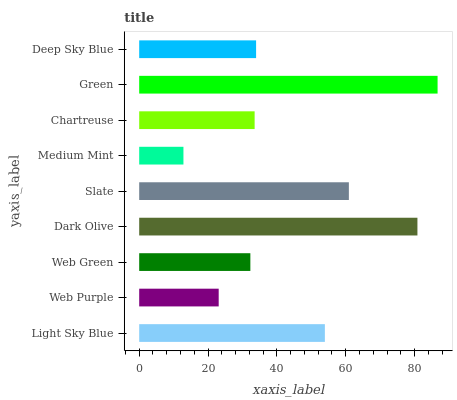Is Medium Mint the minimum?
Answer yes or no. Yes. Is Green the maximum?
Answer yes or no. Yes. Is Web Purple the minimum?
Answer yes or no. No. Is Web Purple the maximum?
Answer yes or no. No. Is Light Sky Blue greater than Web Purple?
Answer yes or no. Yes. Is Web Purple less than Light Sky Blue?
Answer yes or no. Yes. Is Web Purple greater than Light Sky Blue?
Answer yes or no. No. Is Light Sky Blue less than Web Purple?
Answer yes or no. No. Is Deep Sky Blue the high median?
Answer yes or no. Yes. Is Deep Sky Blue the low median?
Answer yes or no. Yes. Is Web Green the high median?
Answer yes or no. No. Is Green the low median?
Answer yes or no. No. 